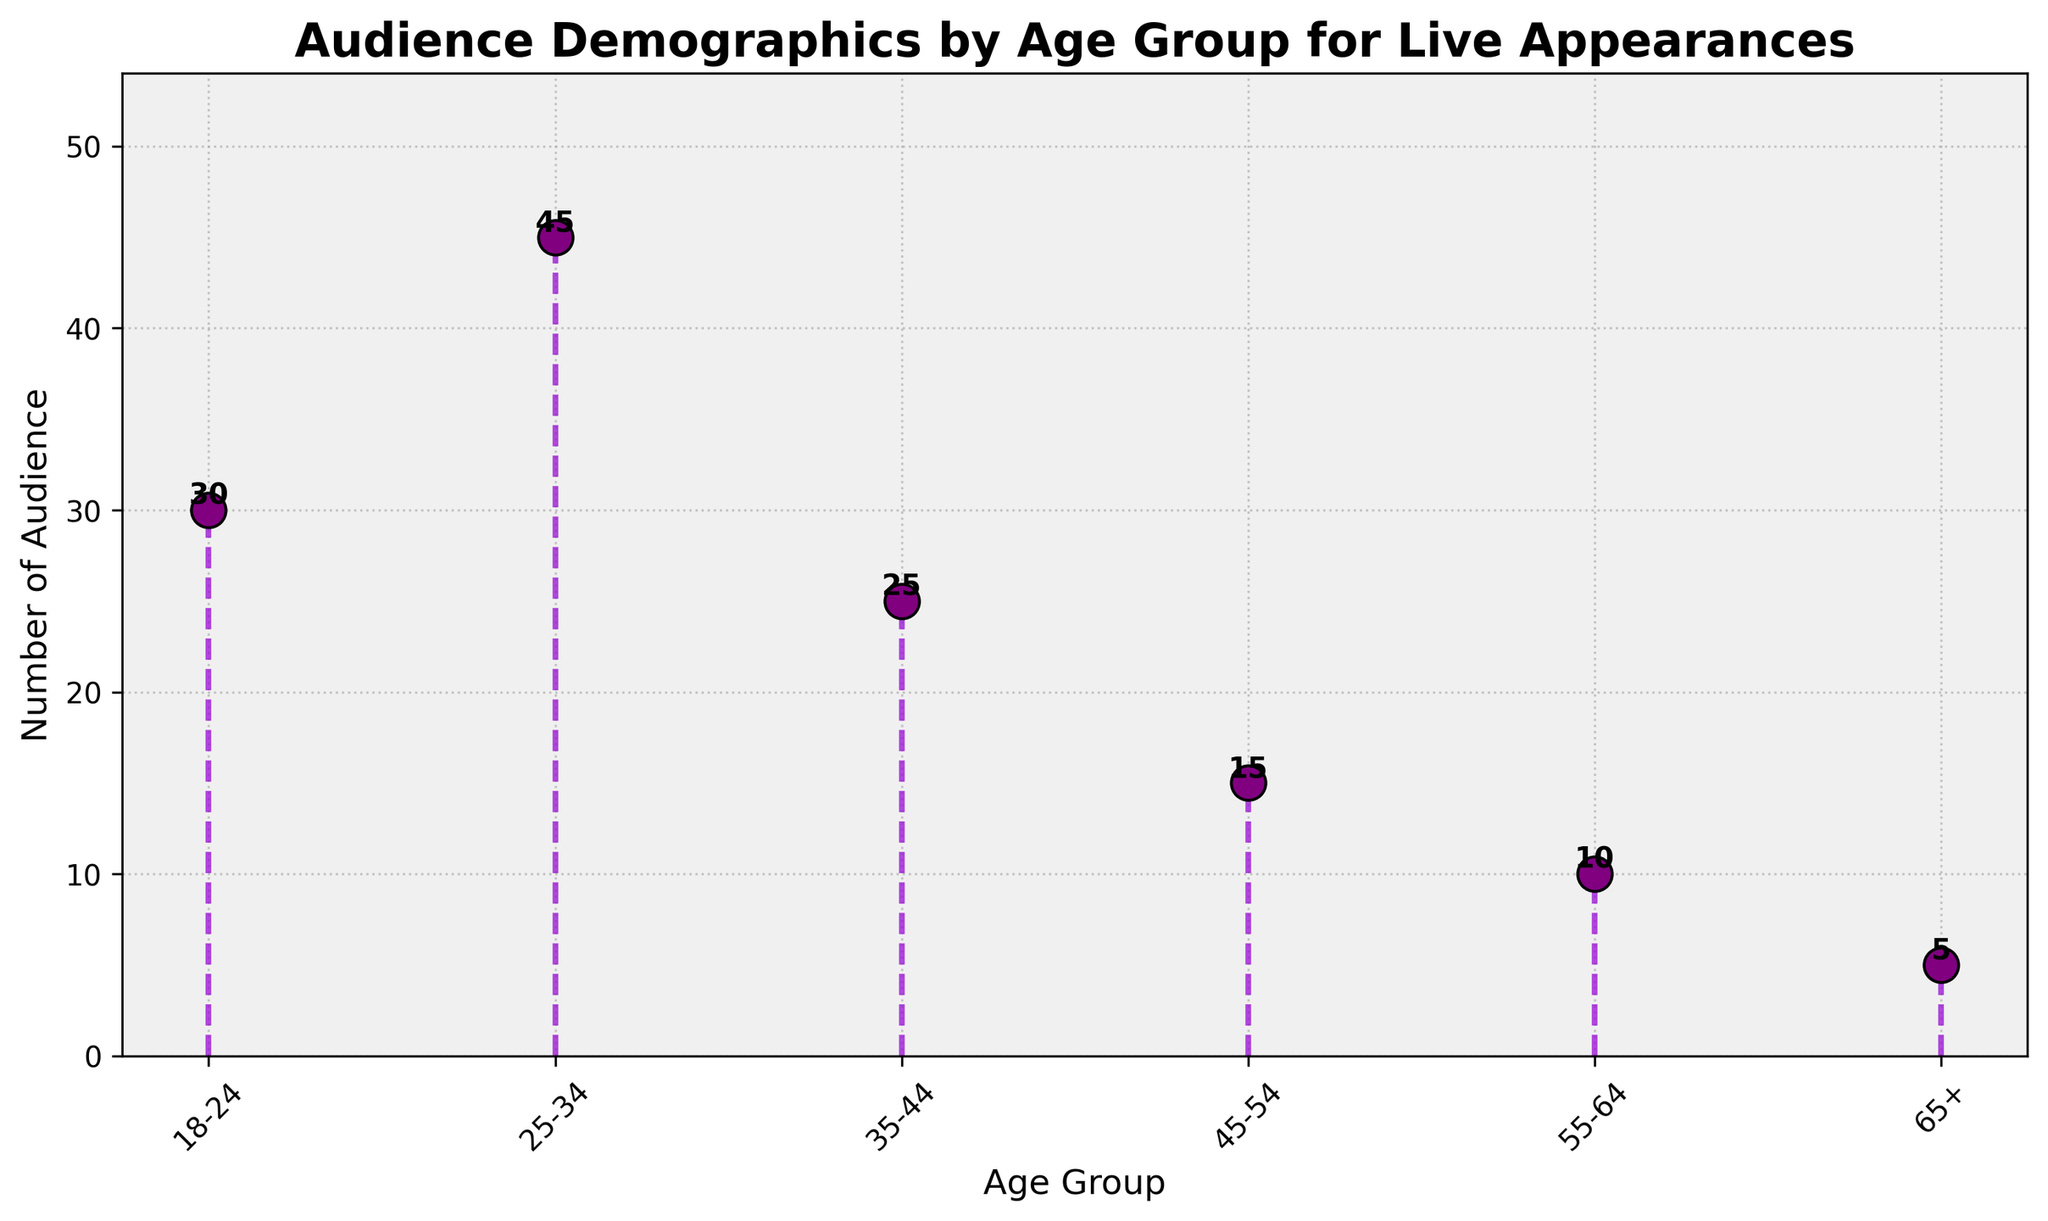What is the title of the plot? The title is found at the top center of the plot and reads "Audience Demographics by Age Group for Live Appearances".
Answer: Audience Demographics by Age Group for Live Appearances Which age group has the highest number of audience members? By looking at the purple markers and the height of the stems, the group 25-34 has the tallest stem, indicating the highest number.
Answer: 25-34 What is the number of audience members for the age group 35-44? The marker on the stem plot corresponding to the age group 35-44 has a number label right above it indicating 25 audience members.
Answer: 25 How many age groups have less than 20 audience members? Checking the labels on each age group, the groups 45-54, 55-64, and 65+ have audience numbers below 20. So, there are 3 such groups.
Answer: 3 What is the total number of audience members across all age groups? Sum the given audience numbers: 30 (18-24) + 45 (25-34) + 25 (35-44) + 15 (45-54) + 10 (55-64) + 5 (65+), which equals 130.
Answer: 130 What are the colors of the marker lines? The marker lines are depicted in a purple color in the plot.
Answer: purple Compare the number of audience members between the 18-24 and 55-64 age groups. The age group 18-24 has 30 audience members, while 55-64 has 10. By taking the difference, 30 - 10, we find that 18-24 has 20 more audience members than 55-64.
Answer: 20 more Which age group has the least amount of audience members and how many are there? By scanning the height of the stems and their value labels, the age group 65+ has the least, with only 5 audience members.
Answer: 65+, 5 What is the average number of audience members per age group? To find the average, sum up the audience numbers: 130, and divide by the number of groups: 6, resulting in 130 / 6 ≈ 21.67.
Answer: ≈ 21.67 Is there an age group with exactly 10 audience members? By looking at the values indicated at the top of the markers, the age group 55-64 has exactly 10 audience members.
Answer: Yes, 55-64 